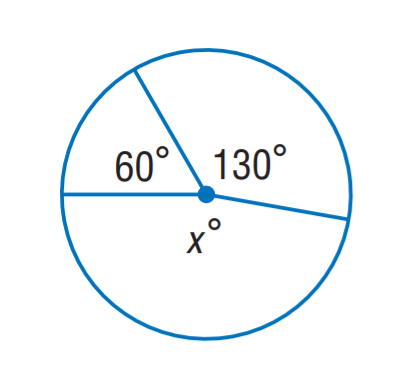Answer the mathemtical geometry problem and directly provide the correct option letter.
Question: Find x.
Choices: A: 130 B: 150 C: 170 D: 190 C 